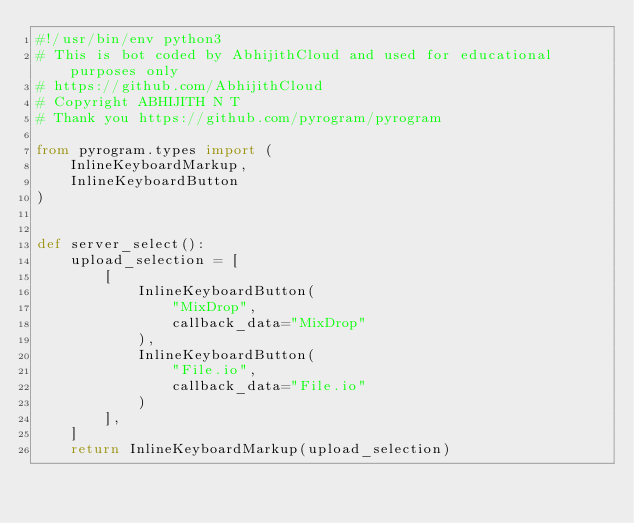<code> <loc_0><loc_0><loc_500><loc_500><_Python_>#!/usr/bin/env python3
# This is bot coded by AbhijithCloud and used for educational purposes only
# https://github.com/AbhijithCloud
# Copyright ABHIJITH N T
# Thank you https://github.com/pyrogram/pyrogram

from pyrogram.types import (
    InlineKeyboardMarkup,
    InlineKeyboardButton
)


def server_select():
    upload_selection = [
        [
            InlineKeyboardButton(
                "MixDrop",
                callback_data="MixDrop"
            ),
            InlineKeyboardButton(
                "File.io",
                callback_data="File.io"
            )
        ],
    ]
    return InlineKeyboardMarkup(upload_selection)
</code> 